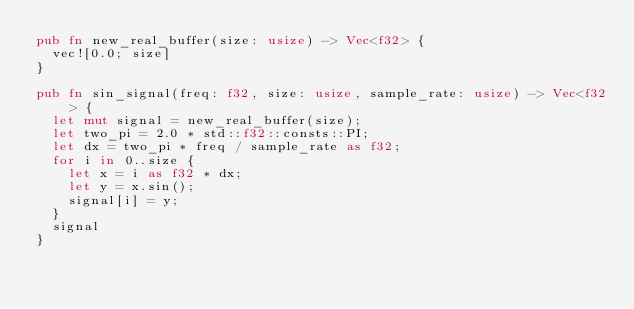Convert code to text. <code><loc_0><loc_0><loc_500><loc_500><_Rust_>pub fn new_real_buffer(size: usize) -> Vec<f32> {
  vec![0.0; size]
}

pub fn sin_signal(freq: f32, size: usize, sample_rate: usize) -> Vec<f32> {
  let mut signal = new_real_buffer(size);
  let two_pi = 2.0 * std::f32::consts::PI;
  let dx = two_pi * freq / sample_rate as f32;
  for i in 0..size {
    let x = i as f32 * dx;
    let y = x.sin();
    signal[i] = y;
  }
  signal
}
</code> 